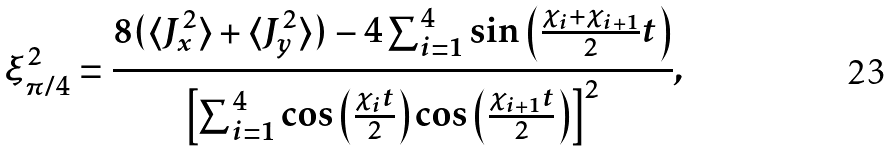Convert formula to latex. <formula><loc_0><loc_0><loc_500><loc_500>\xi _ { \pi / 4 } ^ { 2 } = \frac { 8 ( \langle J _ { x } ^ { 2 } \rangle + \langle J _ { y } ^ { 2 } \rangle ) - 4 \sum _ { i = 1 } ^ { 4 } \sin \left ( \frac { \chi _ { i } + \chi _ { i + 1 } } 2 t \right ) } { \left [ \sum _ { i = 1 } ^ { 4 } \cos \left ( \frac { \chi _ { i } t } 2 \right ) \cos \left ( \frac { \chi _ { i + 1 } t } 2 \right ) \right ] ^ { 2 } } ,</formula> 